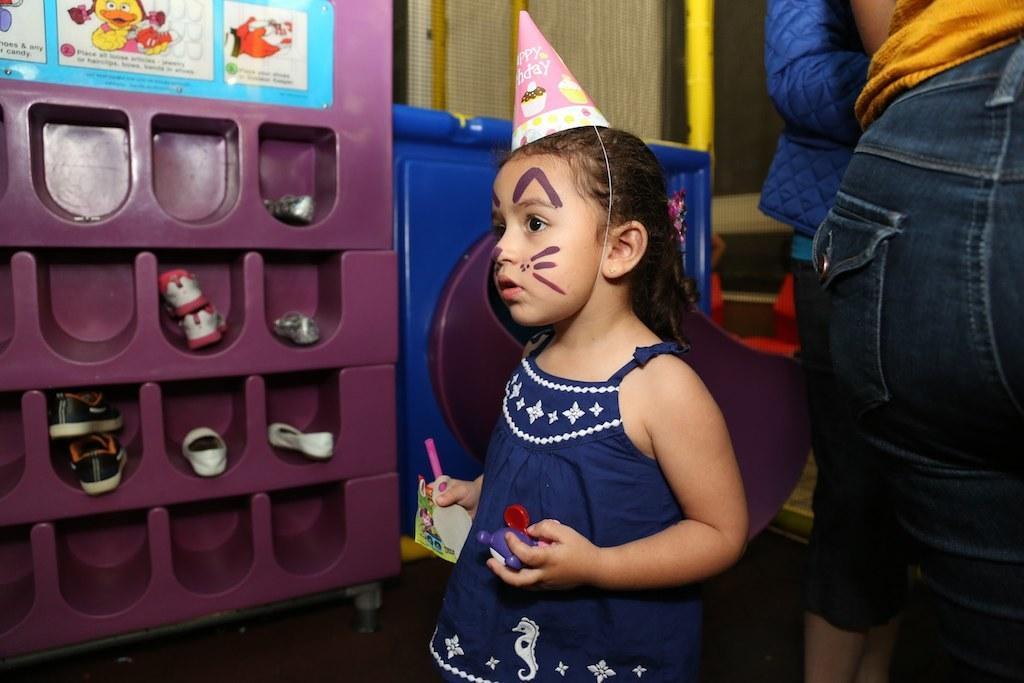Could you give a brief overview of what you see in this image? In this image I see a girl who is wearing white and blue dress and I see a hat on her head on which there are 2 words written and I see pictures of cupcakes and I see the girl is holding few things in her hands and I see 2 persons over here and I see there are shoes in this thing and I see the blue color thing over here and I see pictures and words on this blue color thing. 